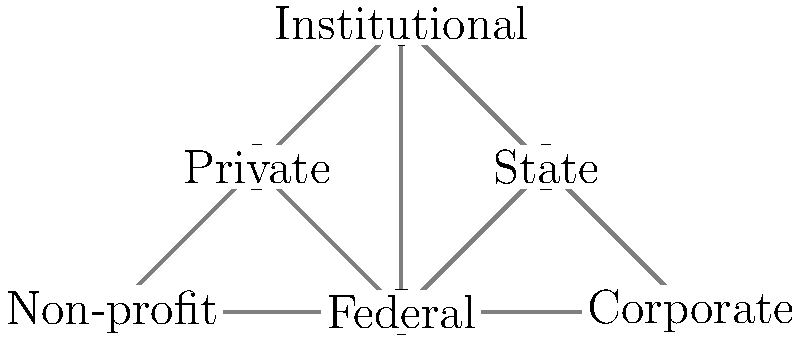In the topology of scholarship funding sources, which node has the highest degree centrality, and how does this impact the overall structure of student financial aid? To answer this question, we need to follow these steps:

1. Understand degree centrality:
   Degree centrality is the number of direct connections a node has to other nodes in the network.

2. Count connections for each node:
   - Federal: 5 connections (State, Private, Institutional, Corporate, Non-profit)
   - State: 3 connections (Federal, Institutional, Corporate)
   - Private: 3 connections (Federal, Institutional, Non-profit)
   - Institutional: 3 connections (Federal, State, Private)
   - Corporate: 2 connections (Federal, State)
   - Non-profit: 2 connections (Federal, Private)

3. Identify the node with the highest degree centrality:
   The Federal node has the highest degree centrality with 5 connections.

4. Analyze the impact on student financial aid:
   a) Centralized structure: The Federal node acts as a hub, connecting all other funding sources.
   b) Resource distribution: Federal funding can influence and coordinate with other sources more easily.
   c) Policy influence: Changes in federal policies can have widespread effects on the entire financial aid system.
   d) Diversification: While the Federal node is central, the presence of other interconnected nodes suggests a degree of diversification in funding sources.
   e) Stability: The central role of Federal funding provides stability but also creates dependency.

5. Conclusion:
   The Federal node's high degree centrality indicates its crucial role in coordinating and influencing the overall structure of student financial aid, while also highlighting the interconnected nature of various funding sources.
Answer: Federal; centralizes coordination and influence in financial aid system 